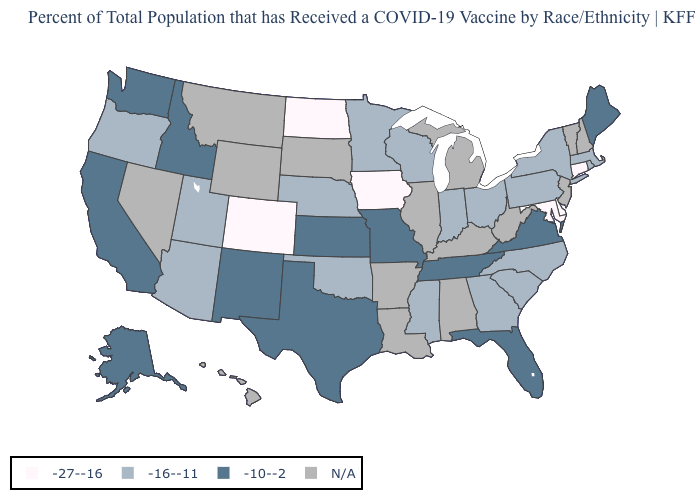What is the value of Nevada?
Keep it brief. N/A. What is the value of Vermont?
Concise answer only. N/A. What is the value of West Virginia?
Be succinct. N/A. What is the value of Wisconsin?
Be succinct. -16--11. How many symbols are there in the legend?
Be succinct. 4. What is the value of Alaska?
Short answer required. -10--2. Does Tennessee have the highest value in the USA?
Answer briefly. Yes. Does Iowa have the highest value in the MidWest?
Short answer required. No. Does North Dakota have the lowest value in the MidWest?
Write a very short answer. Yes. What is the value of Connecticut?
Give a very brief answer. -27--16. Among the states that border South Dakota , does North Dakota have the highest value?
Answer briefly. No. Name the states that have a value in the range -27--16?
Quick response, please. Colorado, Connecticut, Delaware, Iowa, Maryland, North Dakota. How many symbols are there in the legend?
Keep it brief. 4. Does the map have missing data?
Quick response, please. Yes. 